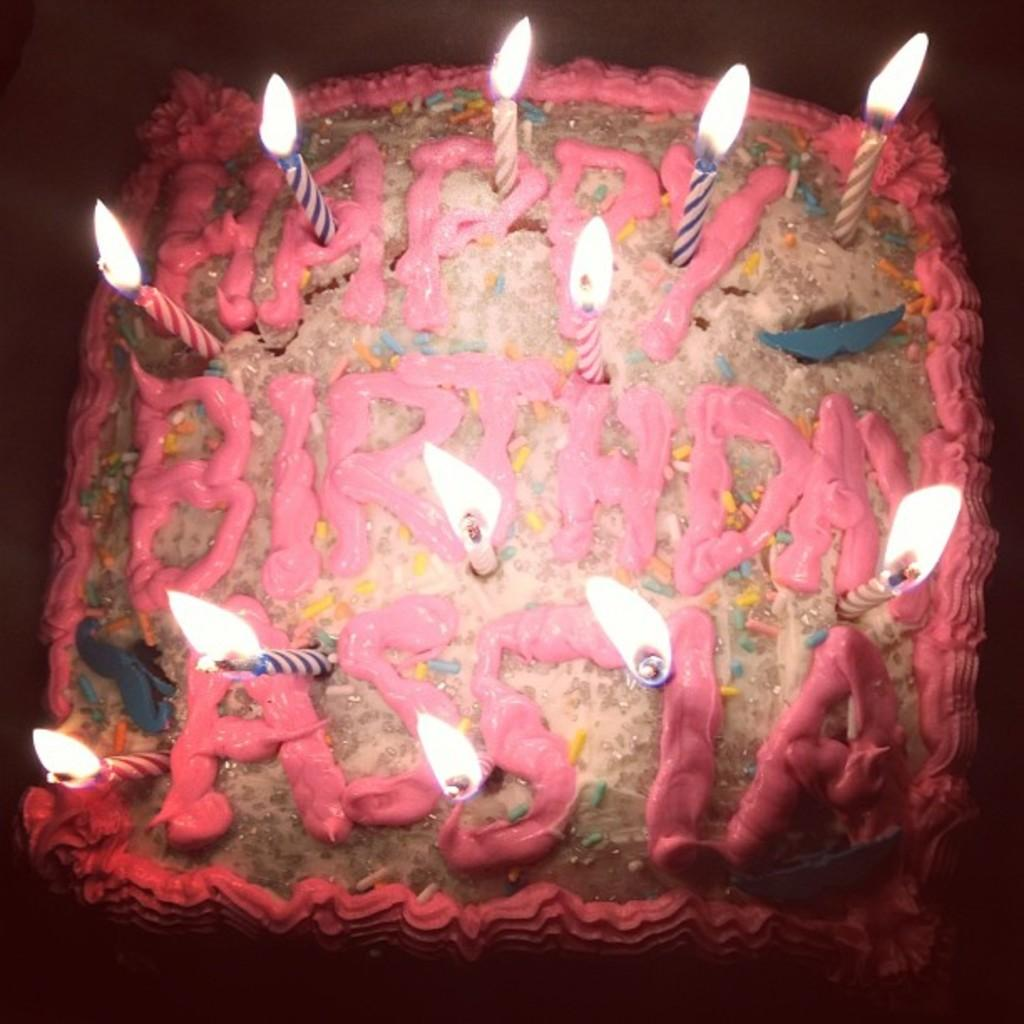What is on top of the cake in the image? There are candles on the cake. What is a characteristic of the candles on the cake? The candles have flames. What type of blade can be seen cutting through the pancake in the image? There is no pancake or blade present in the image; it features a cake with candles. 